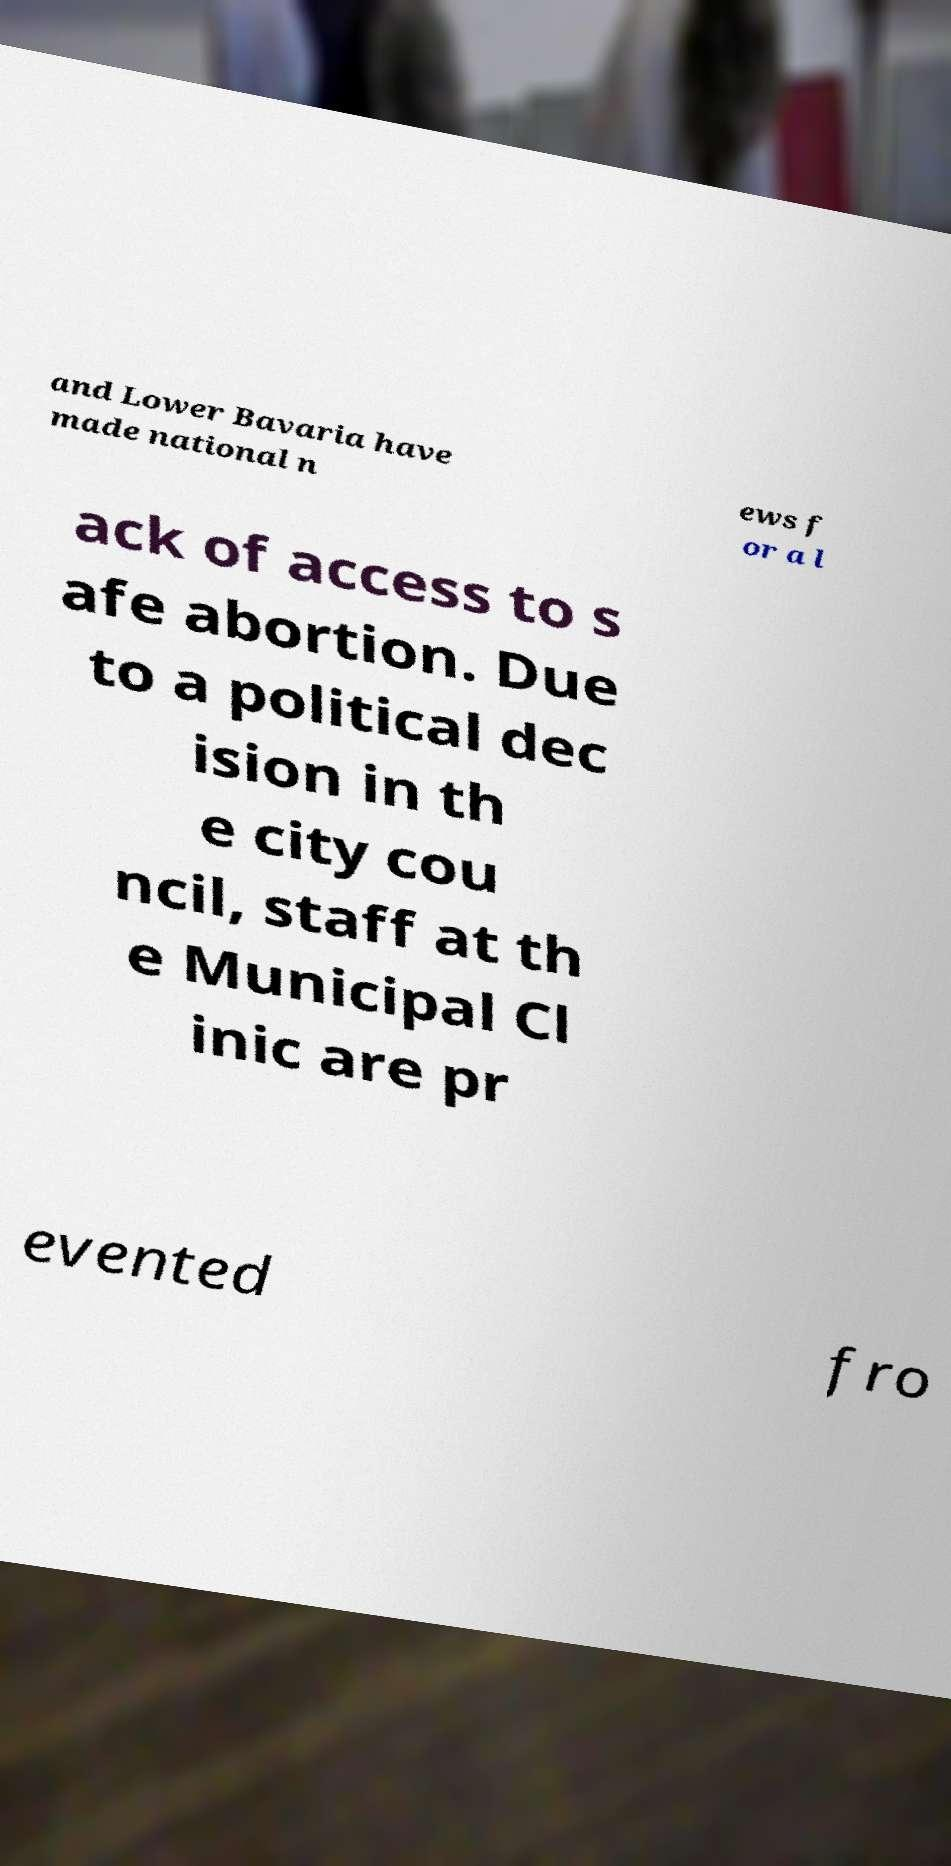Please identify and transcribe the text found in this image. and Lower Bavaria have made national n ews f or a l ack of access to s afe abortion. Due to a political dec ision in th e city cou ncil, staff at th e Municipal Cl inic are pr evented fro 